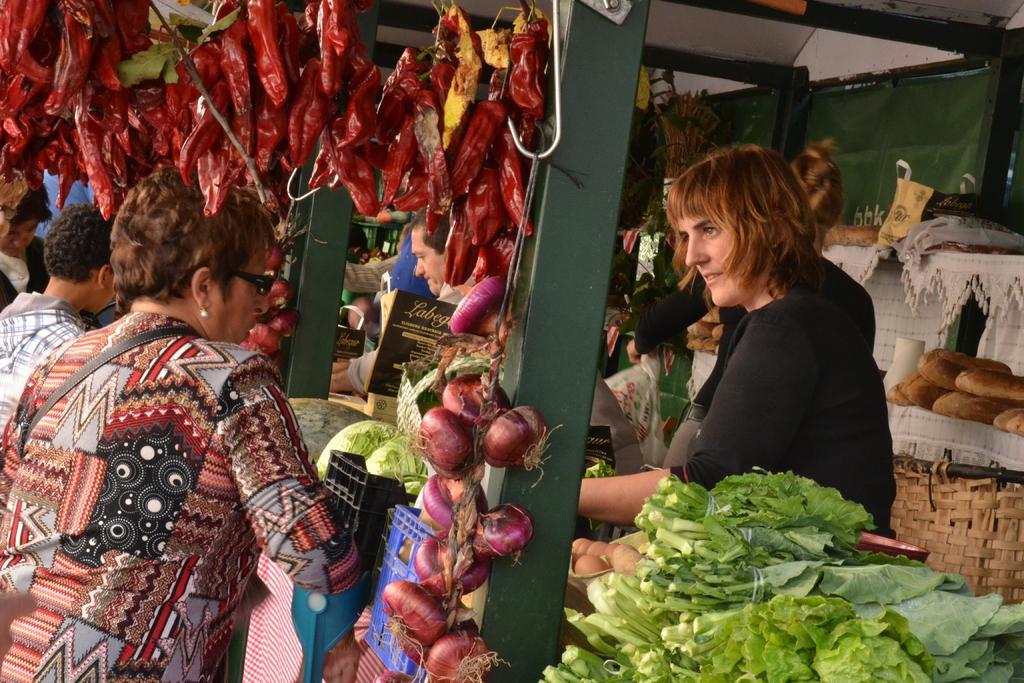Please provide a concise description of this image. In this image I can see a shop ,in the shop I can see vegetables and I can see few persons visible in the shop 